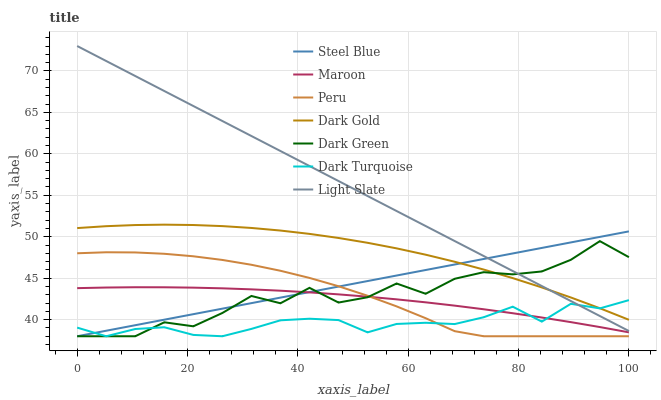Does Dark Turquoise have the minimum area under the curve?
Answer yes or no. Yes. Does Light Slate have the maximum area under the curve?
Answer yes or no. Yes. Does Light Slate have the minimum area under the curve?
Answer yes or no. No. Does Dark Turquoise have the maximum area under the curve?
Answer yes or no. No. Is Steel Blue the smoothest?
Answer yes or no. Yes. Is Dark Green the roughest?
Answer yes or no. Yes. Is Light Slate the smoothest?
Answer yes or no. No. Is Light Slate the roughest?
Answer yes or no. No. Does Dark Turquoise have the lowest value?
Answer yes or no. Yes. Does Light Slate have the lowest value?
Answer yes or no. No. Does Light Slate have the highest value?
Answer yes or no. Yes. Does Dark Turquoise have the highest value?
Answer yes or no. No. Is Peru less than Light Slate?
Answer yes or no. Yes. Is Dark Gold greater than Peru?
Answer yes or no. Yes. Does Light Slate intersect Steel Blue?
Answer yes or no. Yes. Is Light Slate less than Steel Blue?
Answer yes or no. No. Is Light Slate greater than Steel Blue?
Answer yes or no. No. Does Peru intersect Light Slate?
Answer yes or no. No. 